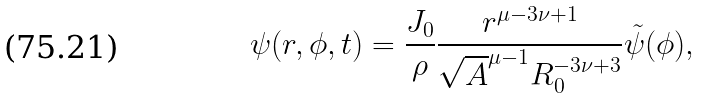<formula> <loc_0><loc_0><loc_500><loc_500>\psi ( r , \phi , t ) = \frac { J _ { 0 } } \rho \frac { r ^ { \mu - 3 \nu + 1 } } { \sqrt { A } ^ { \mu - 1 } R _ { 0 } ^ { - 3 \nu + 3 } } \tilde { \psi } ( \phi ) ,</formula> 